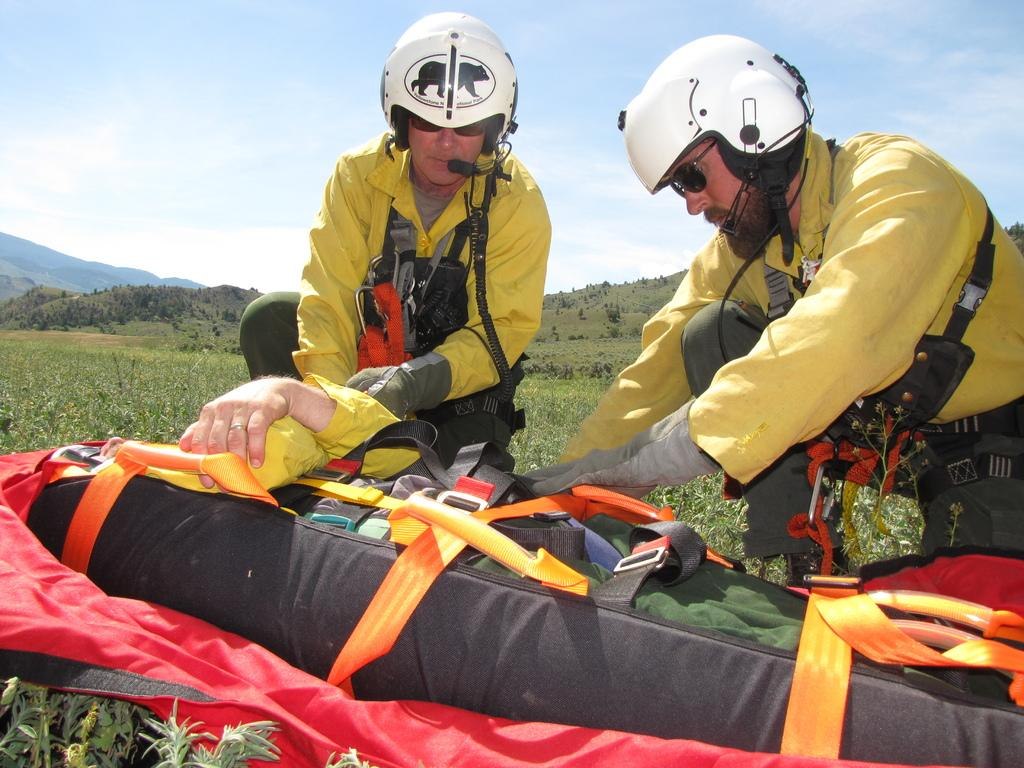How many people can be seen on the path in the image? There are two men on a path in the image. What is the person in the image doing or carrying? There is a person on a stretcher or carrying a bag in the image. What type of natural environment is visible in the background of the image? There are plants and trees in the background of the image. What type of muscle can be seen flexing in the image? There is no muscle flexing visible in the image. How many cats are present in the image? There are no cats present in the image. 